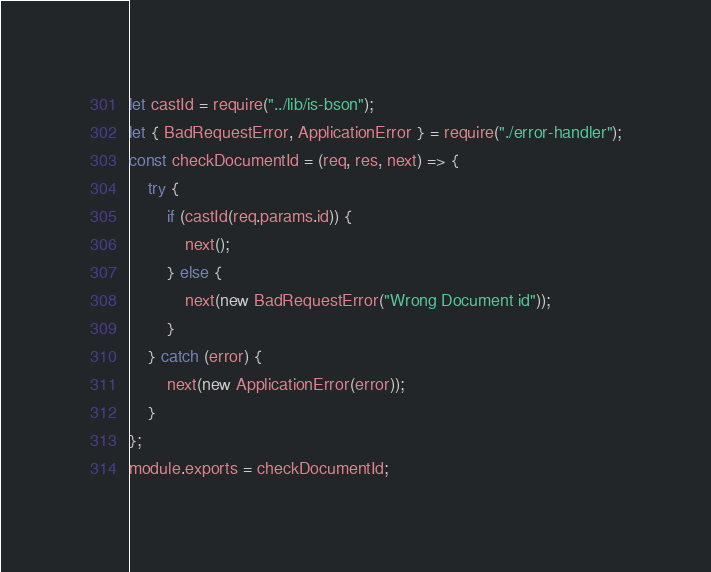Convert code to text. <code><loc_0><loc_0><loc_500><loc_500><_JavaScript_>let castId = require("../lib/is-bson");
let { BadRequestError, ApplicationError } = require("./error-handler");
const checkDocumentId = (req, res, next) => {
    try {
        if (castId(req.params.id)) {
            next();
        } else {
            next(new BadRequestError("Wrong Document id"));
        }
    } catch (error) {
        next(new ApplicationError(error));
    }
};
module.exports = checkDocumentId;
</code> 